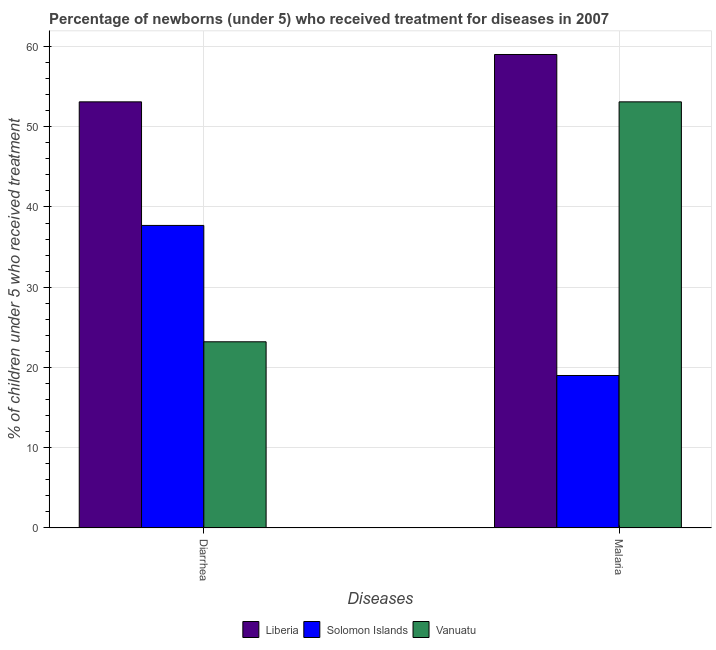How many different coloured bars are there?
Provide a short and direct response. 3. Are the number of bars on each tick of the X-axis equal?
Keep it short and to the point. Yes. How many bars are there on the 2nd tick from the left?
Provide a succinct answer. 3. What is the label of the 2nd group of bars from the left?
Give a very brief answer. Malaria. What is the percentage of children who received treatment for diarrhoea in Vanuatu?
Provide a succinct answer. 23.2. Across all countries, what is the maximum percentage of children who received treatment for diarrhoea?
Provide a succinct answer. 53.1. Across all countries, what is the minimum percentage of children who received treatment for malaria?
Keep it short and to the point. 19. In which country was the percentage of children who received treatment for malaria maximum?
Offer a very short reply. Liberia. In which country was the percentage of children who received treatment for malaria minimum?
Provide a short and direct response. Solomon Islands. What is the total percentage of children who received treatment for diarrhoea in the graph?
Offer a terse response. 114. What is the difference between the percentage of children who received treatment for malaria in Vanuatu and that in Liberia?
Make the answer very short. -5.9. What is the difference between the percentage of children who received treatment for malaria in Vanuatu and the percentage of children who received treatment for diarrhoea in Solomon Islands?
Your answer should be compact. 15.4. What is the average percentage of children who received treatment for malaria per country?
Give a very brief answer. 43.7. What is the difference between the percentage of children who received treatment for malaria and percentage of children who received treatment for diarrhoea in Vanuatu?
Offer a very short reply. 29.9. What is the ratio of the percentage of children who received treatment for malaria in Vanuatu to that in Liberia?
Keep it short and to the point. 0.9. What does the 1st bar from the left in Diarrhea represents?
Your answer should be compact. Liberia. What does the 2nd bar from the right in Malaria represents?
Keep it short and to the point. Solomon Islands. How many bars are there?
Provide a short and direct response. 6. How many countries are there in the graph?
Give a very brief answer. 3. Are the values on the major ticks of Y-axis written in scientific E-notation?
Provide a succinct answer. No. Does the graph contain any zero values?
Your answer should be very brief. No. Does the graph contain grids?
Provide a short and direct response. Yes. How many legend labels are there?
Offer a terse response. 3. What is the title of the graph?
Your response must be concise. Percentage of newborns (under 5) who received treatment for diseases in 2007. Does "Macao" appear as one of the legend labels in the graph?
Keep it short and to the point. No. What is the label or title of the X-axis?
Keep it short and to the point. Diseases. What is the label or title of the Y-axis?
Offer a very short reply. % of children under 5 who received treatment. What is the % of children under 5 who received treatment in Liberia in Diarrhea?
Ensure brevity in your answer.  53.1. What is the % of children under 5 who received treatment of Solomon Islands in Diarrhea?
Provide a succinct answer. 37.7. What is the % of children under 5 who received treatment in Vanuatu in Diarrhea?
Ensure brevity in your answer.  23.2. What is the % of children under 5 who received treatment of Liberia in Malaria?
Provide a short and direct response. 59. What is the % of children under 5 who received treatment in Solomon Islands in Malaria?
Keep it short and to the point. 19. What is the % of children under 5 who received treatment of Vanuatu in Malaria?
Ensure brevity in your answer.  53.1. Across all Diseases, what is the maximum % of children under 5 who received treatment in Liberia?
Make the answer very short. 59. Across all Diseases, what is the maximum % of children under 5 who received treatment in Solomon Islands?
Your response must be concise. 37.7. Across all Diseases, what is the maximum % of children under 5 who received treatment in Vanuatu?
Your answer should be compact. 53.1. Across all Diseases, what is the minimum % of children under 5 who received treatment of Liberia?
Offer a very short reply. 53.1. Across all Diseases, what is the minimum % of children under 5 who received treatment of Vanuatu?
Make the answer very short. 23.2. What is the total % of children under 5 who received treatment in Liberia in the graph?
Ensure brevity in your answer.  112.1. What is the total % of children under 5 who received treatment of Solomon Islands in the graph?
Give a very brief answer. 56.7. What is the total % of children under 5 who received treatment in Vanuatu in the graph?
Make the answer very short. 76.3. What is the difference between the % of children under 5 who received treatment in Solomon Islands in Diarrhea and that in Malaria?
Offer a terse response. 18.7. What is the difference between the % of children under 5 who received treatment of Vanuatu in Diarrhea and that in Malaria?
Your response must be concise. -29.9. What is the difference between the % of children under 5 who received treatment of Liberia in Diarrhea and the % of children under 5 who received treatment of Solomon Islands in Malaria?
Your response must be concise. 34.1. What is the difference between the % of children under 5 who received treatment of Solomon Islands in Diarrhea and the % of children under 5 who received treatment of Vanuatu in Malaria?
Your answer should be compact. -15.4. What is the average % of children under 5 who received treatment in Liberia per Diseases?
Give a very brief answer. 56.05. What is the average % of children under 5 who received treatment in Solomon Islands per Diseases?
Offer a terse response. 28.35. What is the average % of children under 5 who received treatment in Vanuatu per Diseases?
Ensure brevity in your answer.  38.15. What is the difference between the % of children under 5 who received treatment of Liberia and % of children under 5 who received treatment of Vanuatu in Diarrhea?
Provide a succinct answer. 29.9. What is the difference between the % of children under 5 who received treatment in Solomon Islands and % of children under 5 who received treatment in Vanuatu in Diarrhea?
Provide a short and direct response. 14.5. What is the difference between the % of children under 5 who received treatment of Liberia and % of children under 5 who received treatment of Vanuatu in Malaria?
Offer a terse response. 5.9. What is the difference between the % of children under 5 who received treatment in Solomon Islands and % of children under 5 who received treatment in Vanuatu in Malaria?
Your answer should be compact. -34.1. What is the ratio of the % of children under 5 who received treatment in Liberia in Diarrhea to that in Malaria?
Keep it short and to the point. 0.9. What is the ratio of the % of children under 5 who received treatment in Solomon Islands in Diarrhea to that in Malaria?
Make the answer very short. 1.98. What is the ratio of the % of children under 5 who received treatment in Vanuatu in Diarrhea to that in Malaria?
Provide a succinct answer. 0.44. What is the difference between the highest and the second highest % of children under 5 who received treatment in Vanuatu?
Keep it short and to the point. 29.9. What is the difference between the highest and the lowest % of children under 5 who received treatment of Solomon Islands?
Offer a terse response. 18.7. What is the difference between the highest and the lowest % of children under 5 who received treatment in Vanuatu?
Your answer should be compact. 29.9. 